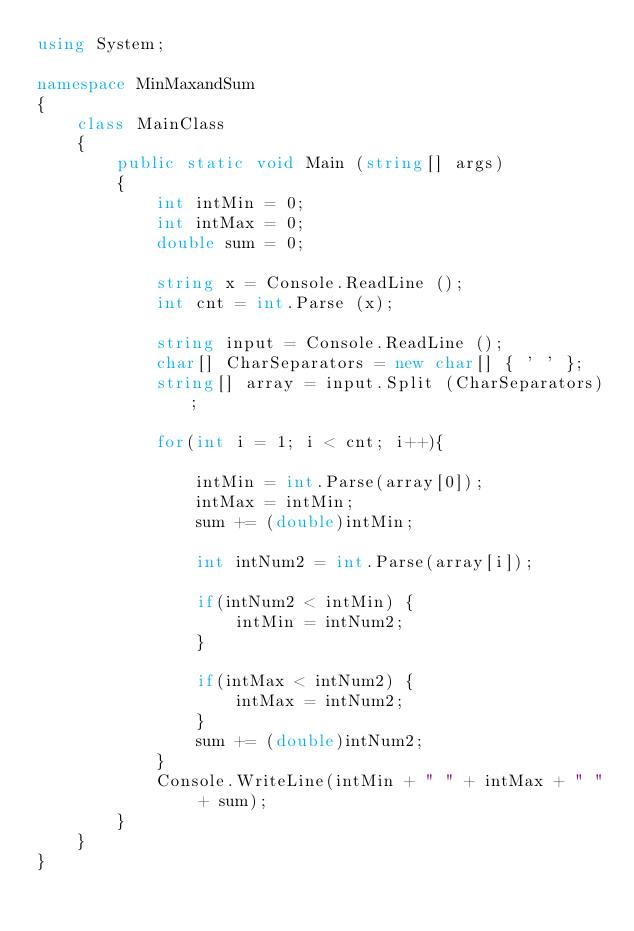<code> <loc_0><loc_0><loc_500><loc_500><_C#_>using System;

namespace MinMaxandSum
{
	class MainClass
	{
		public static void Main (string[] args)
		{
			int intMin = 0;
			int intMax = 0;
			double sum = 0;

			string x = Console.ReadLine ();
			int cnt = int.Parse (x); 

			string input = Console.ReadLine ();
			char[] CharSeparators = new char[] { ' ' };
			string[] array = input.Split (CharSeparators);

			for(int i = 1; i < cnt; i++){

				intMin = int.Parse(array[0]);
				intMax = intMin;
				sum += (double)intMin;

				int intNum2 = int.Parse(array[i]);

				if(intNum2 < intMin) {
					intMin = intNum2;
				}
			
				if(intMax < intNum2) {
					intMax = intNum2;
				}
				sum += (double)intNum2;	
			}
			Console.WriteLine(intMin + " " + intMax + " " + sum);
		}
	}
}</code> 